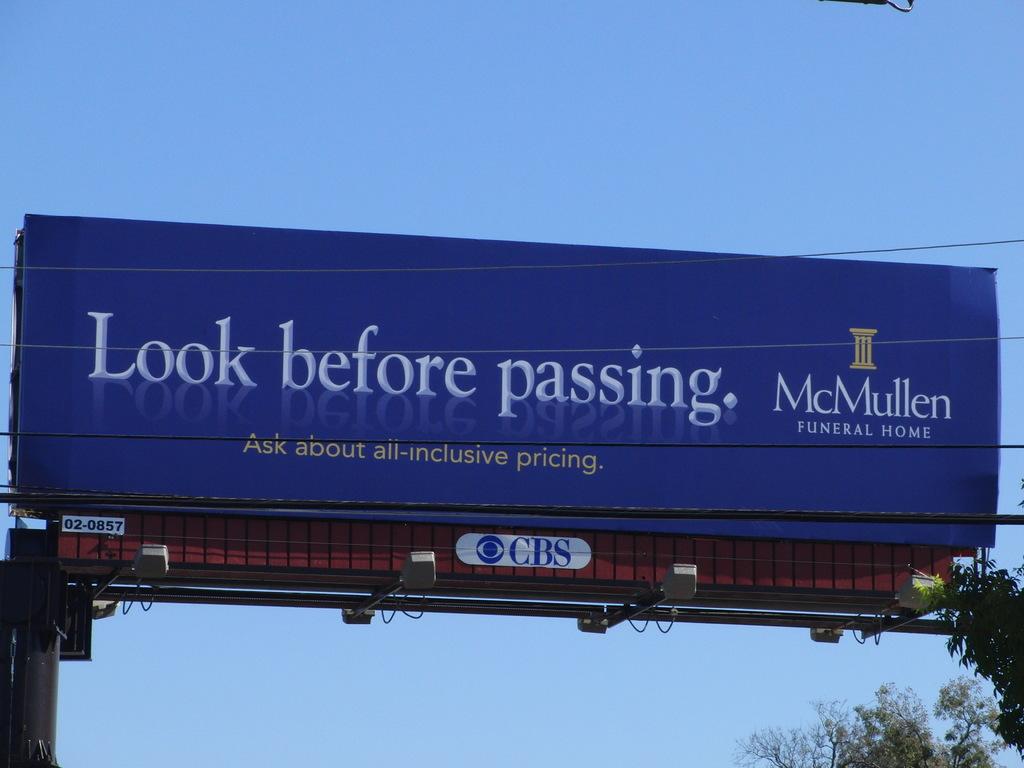What is the name of the funeral home?
Give a very brief answer. Mcmullen. 